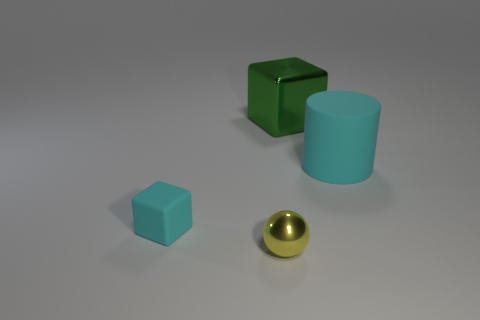Does the large metallic object have the same shape as the cyan thing right of the tiny yellow metal thing?
Make the answer very short. No. What is the big cylinder made of?
Keep it short and to the point. Rubber. How many matte objects are small balls or cyan spheres?
Make the answer very short. 0. Is the number of cyan rubber cylinders behind the big cyan object less than the number of metallic things in front of the yellow metallic sphere?
Keep it short and to the point. No. There is a cyan object in front of the matte thing right of the cyan rubber cube; is there a small cyan cube that is in front of it?
Provide a succinct answer. No. There is a tiny block that is the same color as the big rubber cylinder; what material is it?
Give a very brief answer. Rubber. Does the cyan matte thing that is on the right side of the small cyan rubber thing have the same shape as the big thing on the left side of the big cylinder?
Make the answer very short. No. There is a cyan thing that is the same size as the green shiny thing; what is it made of?
Your response must be concise. Rubber. Is the material of the cyan object to the right of the large green metal object the same as the small object that is behind the metallic ball?
Give a very brief answer. Yes. There is a cyan rubber thing that is the same size as the yellow object; what shape is it?
Your response must be concise. Cube. 